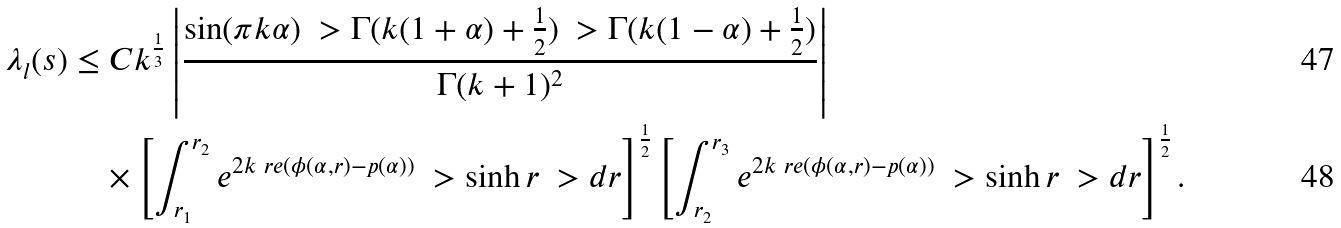<formula> <loc_0><loc_0><loc_500><loc_500>\lambda _ { l } ( s ) & \leq C k ^ { \frac { 1 } { 3 } } \left | \frac { \sin ( \pi k \alpha ) \ > \Gamma ( k ( 1 + \alpha ) + \frac { 1 } { 2 } ) \ > \Gamma ( k ( 1 - \alpha ) + \frac { 1 } { 2 } ) } { \Gamma ( k + 1 ) ^ { 2 } } \right | \\ & \quad \times \left [ \int _ { r _ { 1 } } ^ { r _ { 2 } } e ^ { 2 k \ r e ( \phi ( \alpha , r ) - p ( \alpha ) ) } \ > \sinh r \ > d r \right ] ^ { \frac { 1 } { 2 } } \left [ \int _ { r _ { 2 } } ^ { r _ { 3 } } e ^ { 2 k \ r e ( \phi ( \alpha , r ) - p ( \alpha ) ) } \ > \sinh r \ > d r \right ] ^ { \frac { 1 } { 2 } } .</formula> 